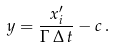<formula> <loc_0><loc_0><loc_500><loc_500>y = \frac { x ^ { \prime } _ { i } } { \Gamma \, \Delta \, t } - c \, .</formula> 